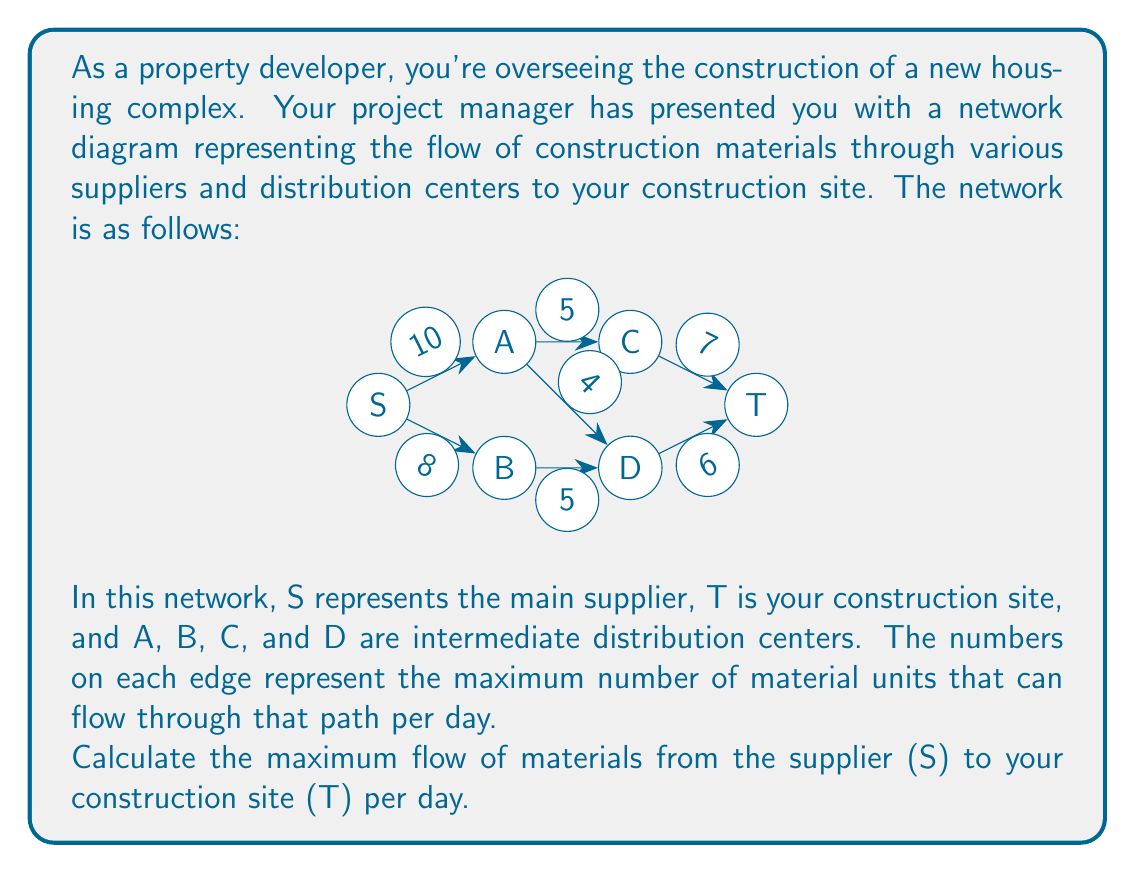Can you answer this question? To solve this problem, we'll use the Ford-Fulkerson algorithm to find the maximum flow in the network. Here's a step-by-step explanation:

1) We start by initializing the flow on all edges to 0.

2) We then find augmenting paths from S to T and push flow along these paths until no more augmenting paths exist.

3) Let's find the augmenting paths:

   Path 1: S -> A -> C -> T
   Minimum capacity = min(10, 5, 7) = 5
   Push 5 units of flow along this path.

   Path 2: S -> A -> D -> T
   Minimum capacity = min(10-5, 4, 6) = 4
   Push 4 units of flow along this path.

   Path 3: S -> B -> D -> T
   Minimum capacity = min(8, 5, 6-4) = 2
   Push 2 units of flow along this path.

4) At this point, there are no more augmenting paths from S to T. All paths from S to T now have at least one saturated edge.

5) The maximum flow is the sum of all flows we pushed:
   5 + 4 + 2 = 11

Therefore, the maximum flow of materials from the supplier to your construction site is 11 units per day.

This solution uses the concept of max-flow min-cut theorem in graph theory, which states that in a flow network, the maximum amount of flow passing from the source to the sink is equal to the minimum capacity that needs to be removed from the network to prevent any flow from the source to the sink.
Answer: The maximum flow of materials from the supplier to the construction site is 11 units per day. 